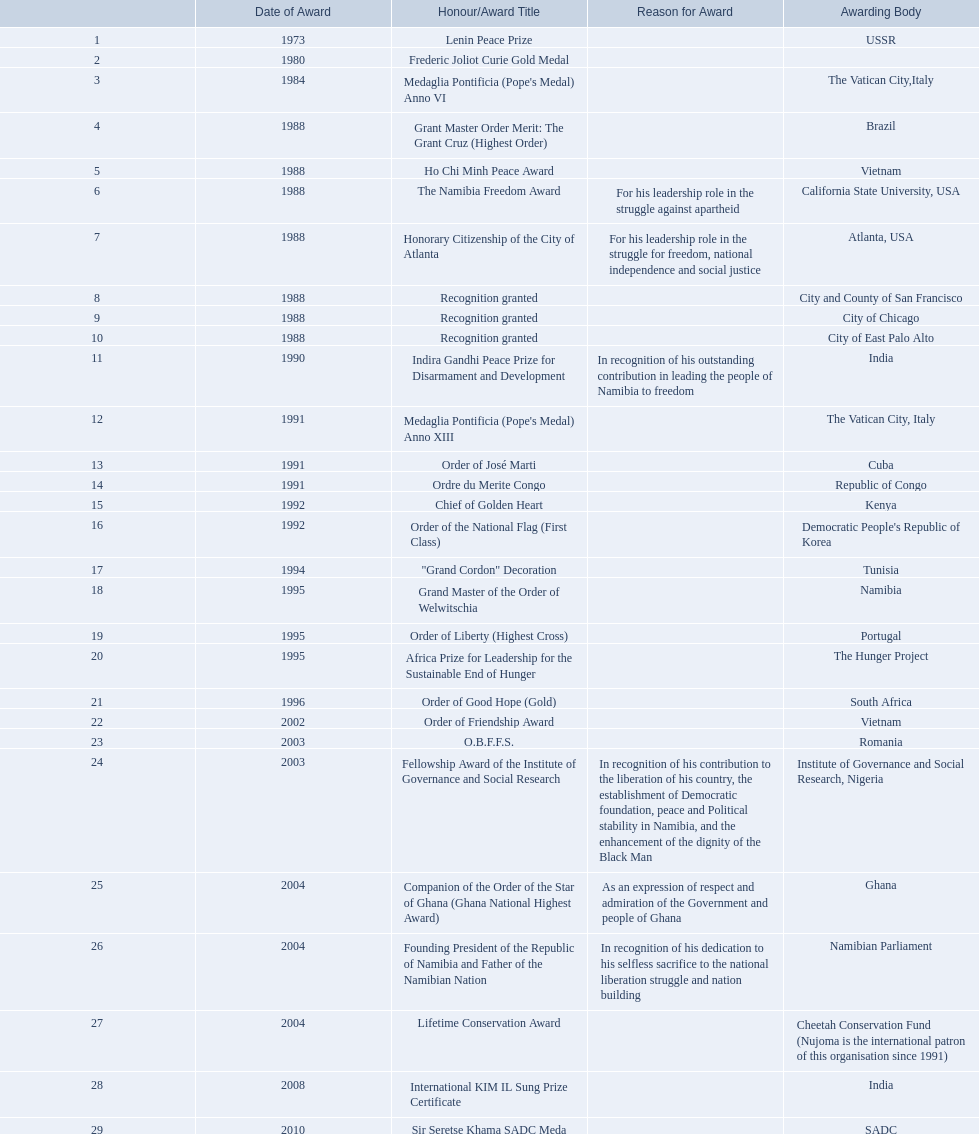Which accolades were bestowed upon sam nujoma? 1, 1973, Lenin Peace Prize, Frederic Joliot Curie Gold Medal, Medaglia Pontificia (Pope's Medal) Anno VI, Grant Master Order Merit: The Grant Cruz (Highest Order), Ho Chi Minh Peace Award, The Namibia Freedom Award, Honorary Citizenship of the City of Atlanta, Recognition granted, Recognition granted, Recognition granted, Indira Gandhi Peace Prize for Disarmament and Development, Medaglia Pontificia (Pope's Medal) Anno XIII, Order of José Marti, Ordre du Merite Congo, Chief of Golden Heart, Order of the National Flag (First Class), "Grand Cordon" Decoration, Grand Master of the Order of Welwitschia, Order of Liberty (Highest Cross), Africa Prize for Leadership for the Sustainable End of Hunger, Order of Good Hope (Gold), Order of Friendship Award, O.B.F.F.S., Fellowship Award of the Institute of Governance and Social Research, Companion of the Order of the Star of Ghana (Ghana National Highest Award), Founding President of the Republic of Namibia and Father of the Namibian Nation, Lifetime Conservation Award, International KIM IL Sung Prize Certificate, Sir Seretse Khama SADC Meda. Who granted the obffs award? Romania. 